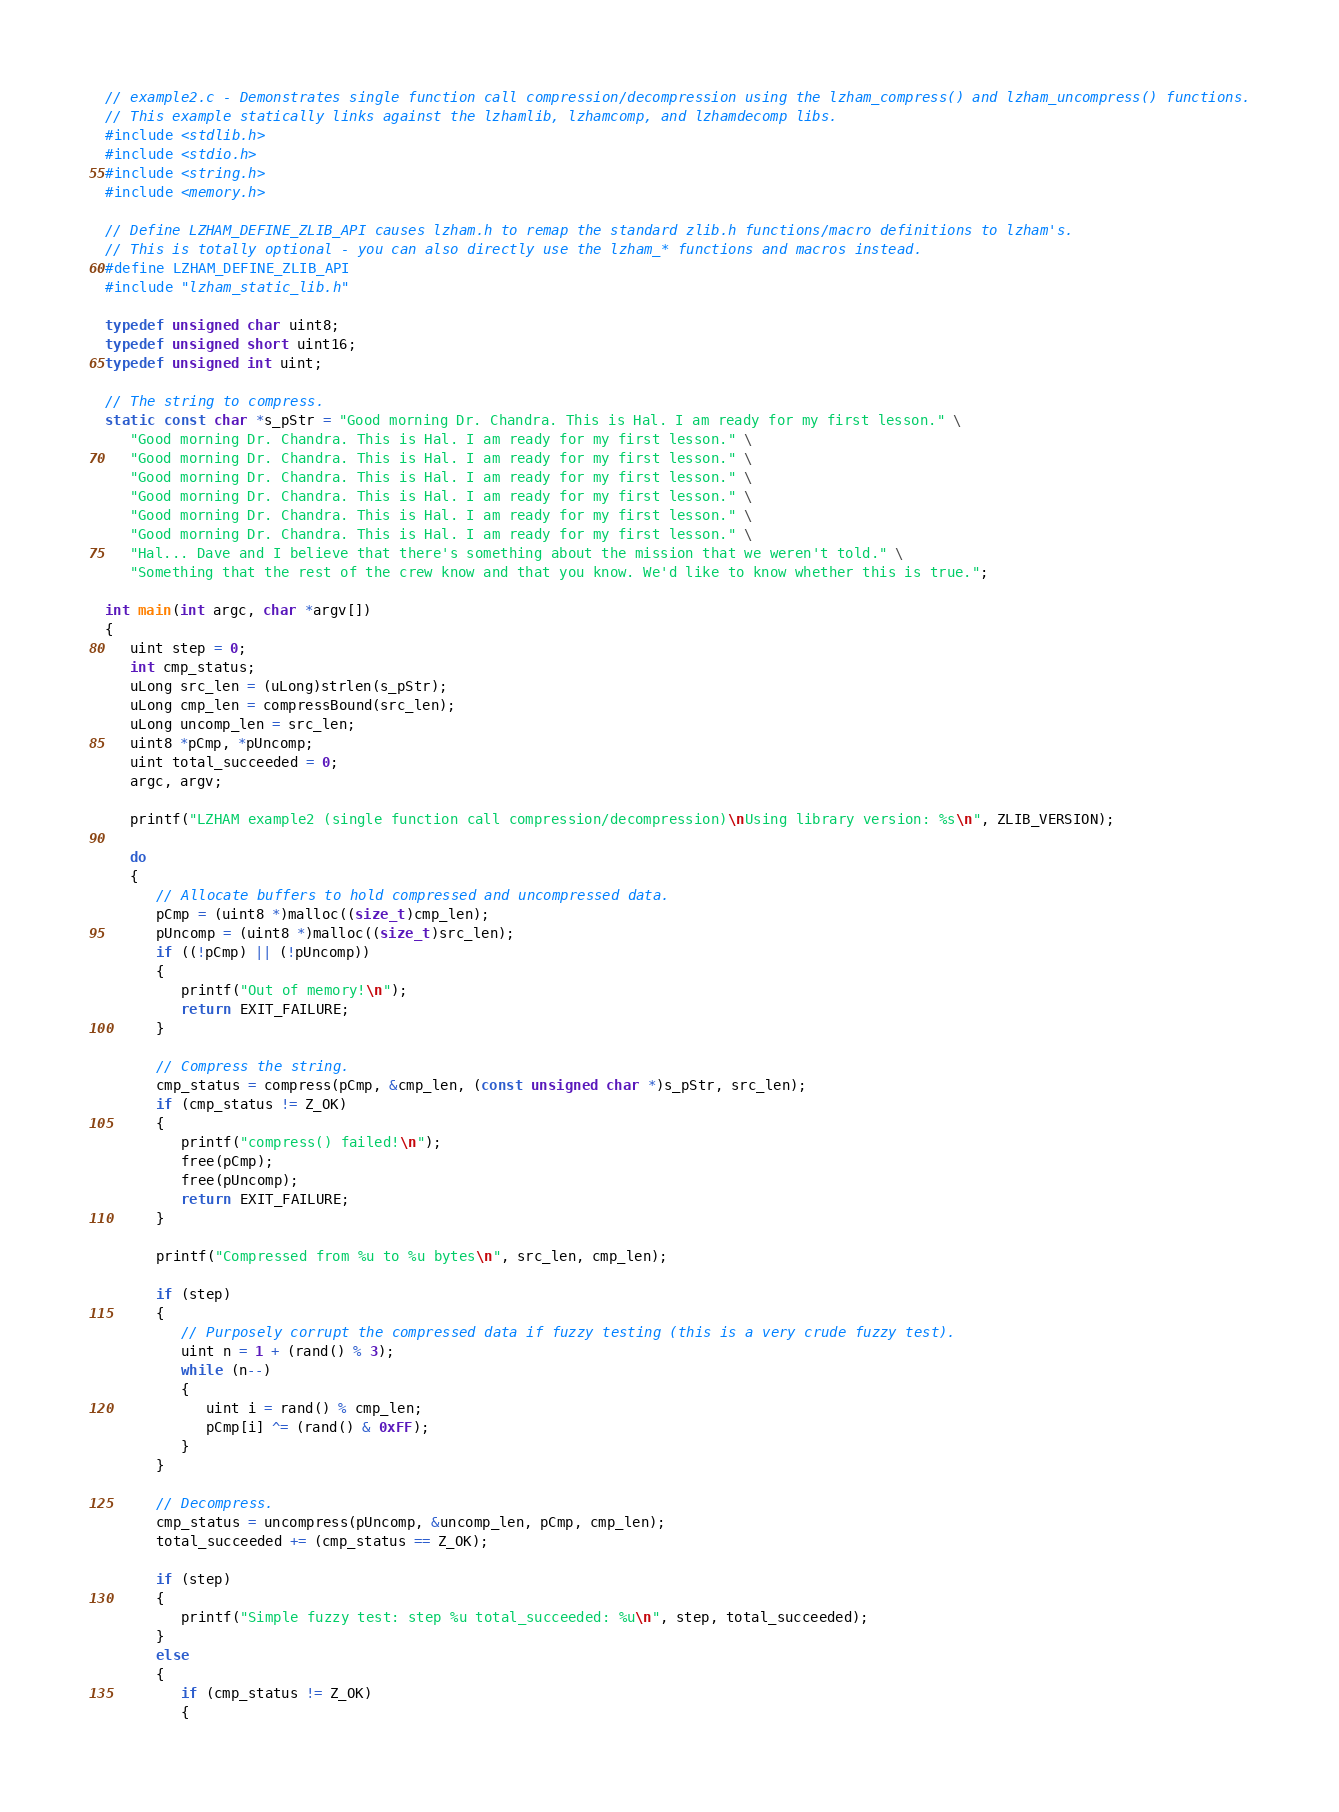<code> <loc_0><loc_0><loc_500><loc_500><_C_>// example2.c - Demonstrates single function call compression/decompression using the lzham_compress() and lzham_uncompress() functions.
// This example statically links against the lzhamlib, lzhamcomp, and lzhamdecomp libs.
#include <stdlib.h>
#include <stdio.h>
#include <string.h>
#include <memory.h>

// Define LZHAM_DEFINE_ZLIB_API causes lzham.h to remap the standard zlib.h functions/macro definitions to lzham's.
// This is totally optional - you can also directly use the lzham_* functions and macros instead.
#define LZHAM_DEFINE_ZLIB_API
#include "lzham_static_lib.h"

typedef unsigned char uint8;
typedef unsigned short uint16;
typedef unsigned int uint;

// The string to compress.
static const char *s_pStr = "Good morning Dr. Chandra. This is Hal. I am ready for my first lesson." \
   "Good morning Dr. Chandra. This is Hal. I am ready for my first lesson." \
   "Good morning Dr. Chandra. This is Hal. I am ready for my first lesson." \
   "Good morning Dr. Chandra. This is Hal. I am ready for my first lesson." \
   "Good morning Dr. Chandra. This is Hal. I am ready for my first lesson." \
   "Good morning Dr. Chandra. This is Hal. I am ready for my first lesson." \
   "Good morning Dr. Chandra. This is Hal. I am ready for my first lesson." \
   "Hal... Dave and I believe that there's something about the mission that we weren't told." \
   "Something that the rest of the crew know and that you know. We'd like to know whether this is true.";

int main(int argc, char *argv[])
{
   uint step = 0;
   int cmp_status;
   uLong src_len = (uLong)strlen(s_pStr);
   uLong cmp_len = compressBound(src_len);
   uLong uncomp_len = src_len;
   uint8 *pCmp, *pUncomp;
   uint total_succeeded = 0;
   argc, argv;

   printf("LZHAM example2 (single function call compression/decompression)\nUsing library version: %s\n", ZLIB_VERSION);

   do
   {
      // Allocate buffers to hold compressed and uncompressed data.
      pCmp = (uint8 *)malloc((size_t)cmp_len);
      pUncomp = (uint8 *)malloc((size_t)src_len);
      if ((!pCmp) || (!pUncomp))
      {
         printf("Out of memory!\n");
         return EXIT_FAILURE;
      }

      // Compress the string.
      cmp_status = compress(pCmp, &cmp_len, (const unsigned char *)s_pStr, src_len);
      if (cmp_status != Z_OK)
      {
         printf("compress() failed!\n");
         free(pCmp);
         free(pUncomp);
         return EXIT_FAILURE;
      }

      printf("Compressed from %u to %u bytes\n", src_len, cmp_len);

      if (step)
      {
         // Purposely corrupt the compressed data if fuzzy testing (this is a very crude fuzzy test).
         uint n = 1 + (rand() % 3);
         while (n--)
         {
            uint i = rand() % cmp_len;
            pCmp[i] ^= (rand() & 0xFF);
         }
      }

      // Decompress.
      cmp_status = uncompress(pUncomp, &uncomp_len, pCmp, cmp_len);
      total_succeeded += (cmp_status == Z_OK);

      if (step)
      {
         printf("Simple fuzzy test: step %u total_succeeded: %u\n", step, total_succeeded);
      }
      else
      {
         if (cmp_status != Z_OK)
         {</code> 